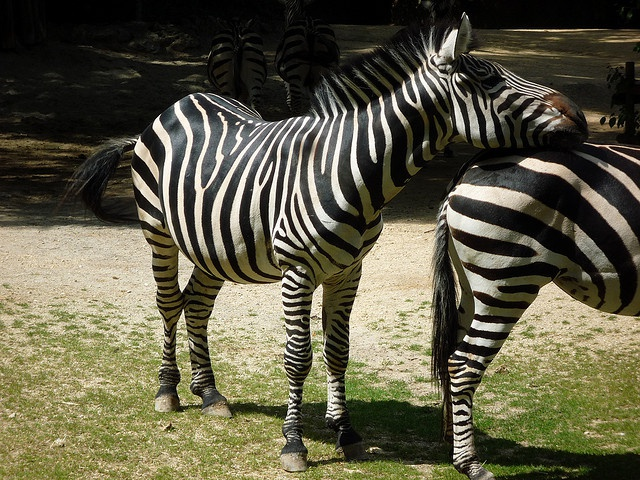Describe the objects in this image and their specific colors. I can see zebra in black, gray, ivory, and darkgreen tones, zebra in black, gray, ivory, and darkgreen tones, zebra in black and gray tones, and zebra in black, gray, and darkgreen tones in this image. 